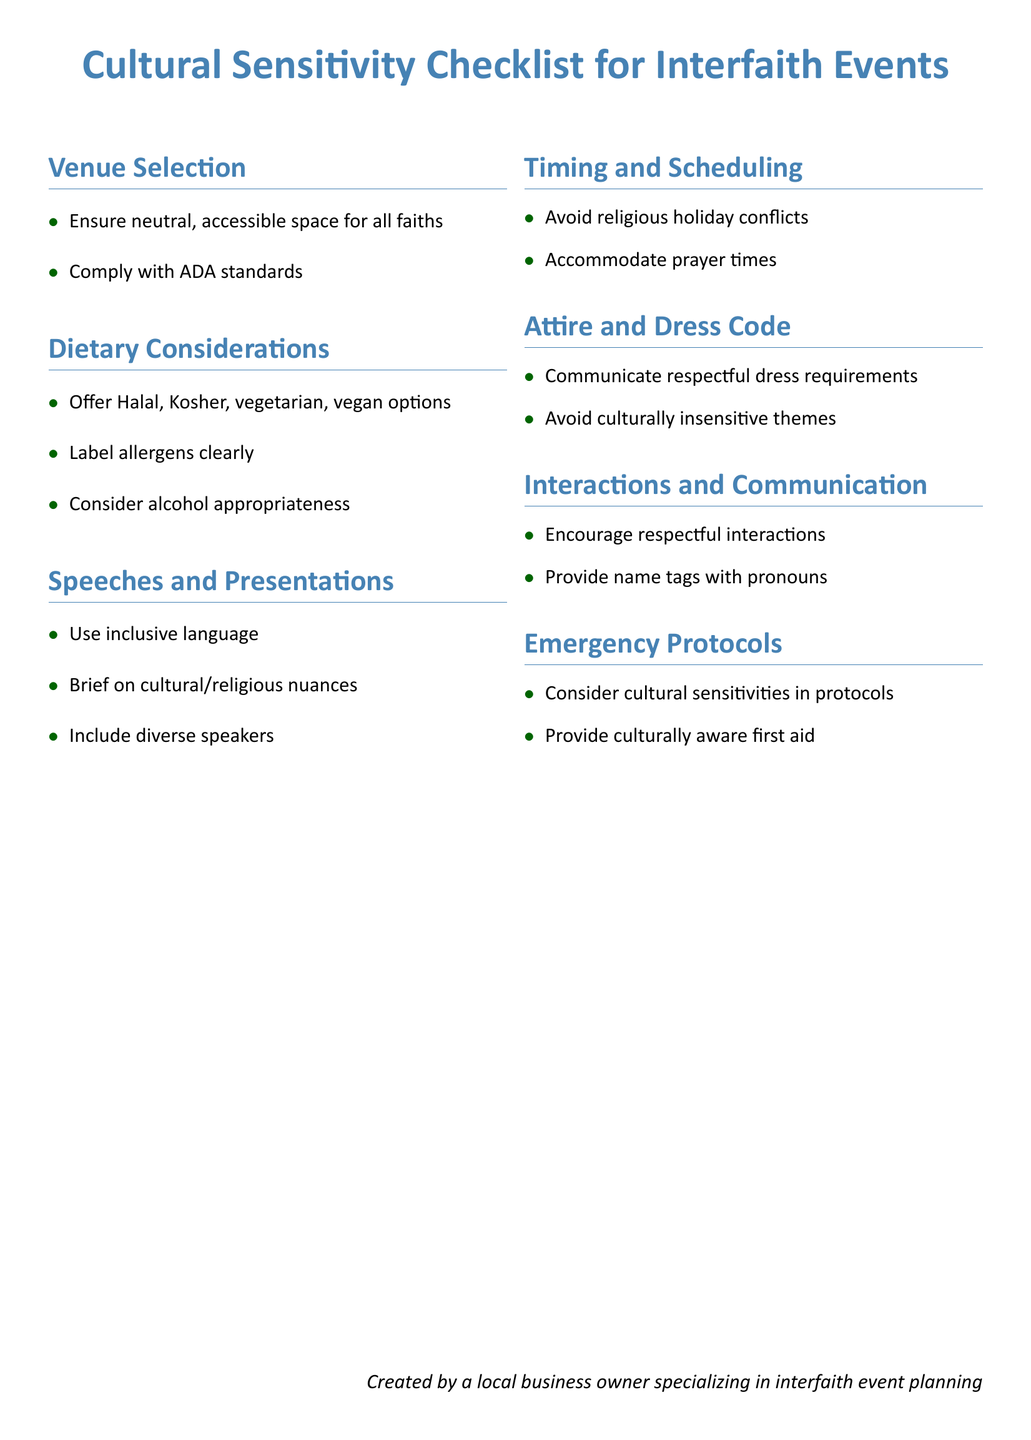What are the dietary options to offer? The document lists options such as Halal, Kosher, vegetarian, and vegan.
Answer: Halal, Kosher, vegetarian, vegan What should be ensured in venue selection? The checklist emphasizes ensuring a neutral, accessible space for all faiths.
Answer: Neutral, accessible space What should speeches and presentations include? The document states that speeches should include diverse speakers.
Answer: Diverse speakers What is advised regarding attire and dress code? The document advises to communicate respectful dress requirements.
Answer: Respectful dress requirements What should be labeled clearly in dietary considerations? Allergens should be labeled clearly according to the checklist.
Answer: Allergens What is the total number of sections in the checklist? The document contains seven sections outlined for the cultural sensitivity checklist.
Answer: Seven What should be considered in emergency protocols? The document mentions considering cultural sensitivities in emergency protocols.
Answer: Cultural sensitivities What does the communication section encourage? The interactions and communication section encourages respectful interactions.
Answer: Respectful interactions 